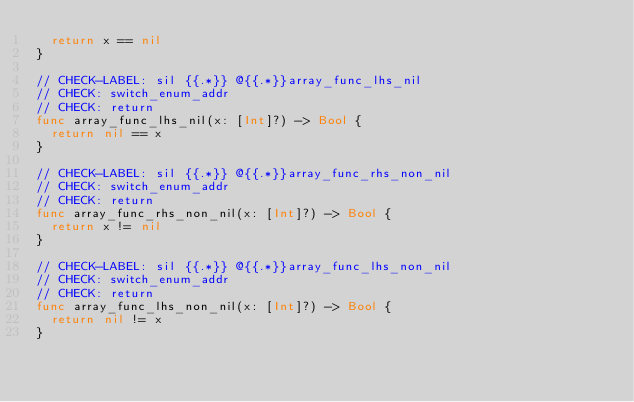<code> <loc_0><loc_0><loc_500><loc_500><_Swift_>  return x == nil
}

// CHECK-LABEL: sil {{.*}} @{{.*}}array_func_lhs_nil
// CHECK: switch_enum_addr
// CHECK: return
func array_func_lhs_nil(x: [Int]?) -> Bool {
  return nil == x
}

// CHECK-LABEL: sil {{.*}} @{{.*}}array_func_rhs_non_nil
// CHECK: switch_enum_addr
// CHECK: return
func array_func_rhs_non_nil(x: [Int]?) -> Bool {
  return x != nil
}

// CHECK-LABEL: sil {{.*}} @{{.*}}array_func_lhs_non_nil
// CHECK: switch_enum_addr
// CHECK: return
func array_func_lhs_non_nil(x: [Int]?) -> Bool {
  return nil != x
}

</code> 